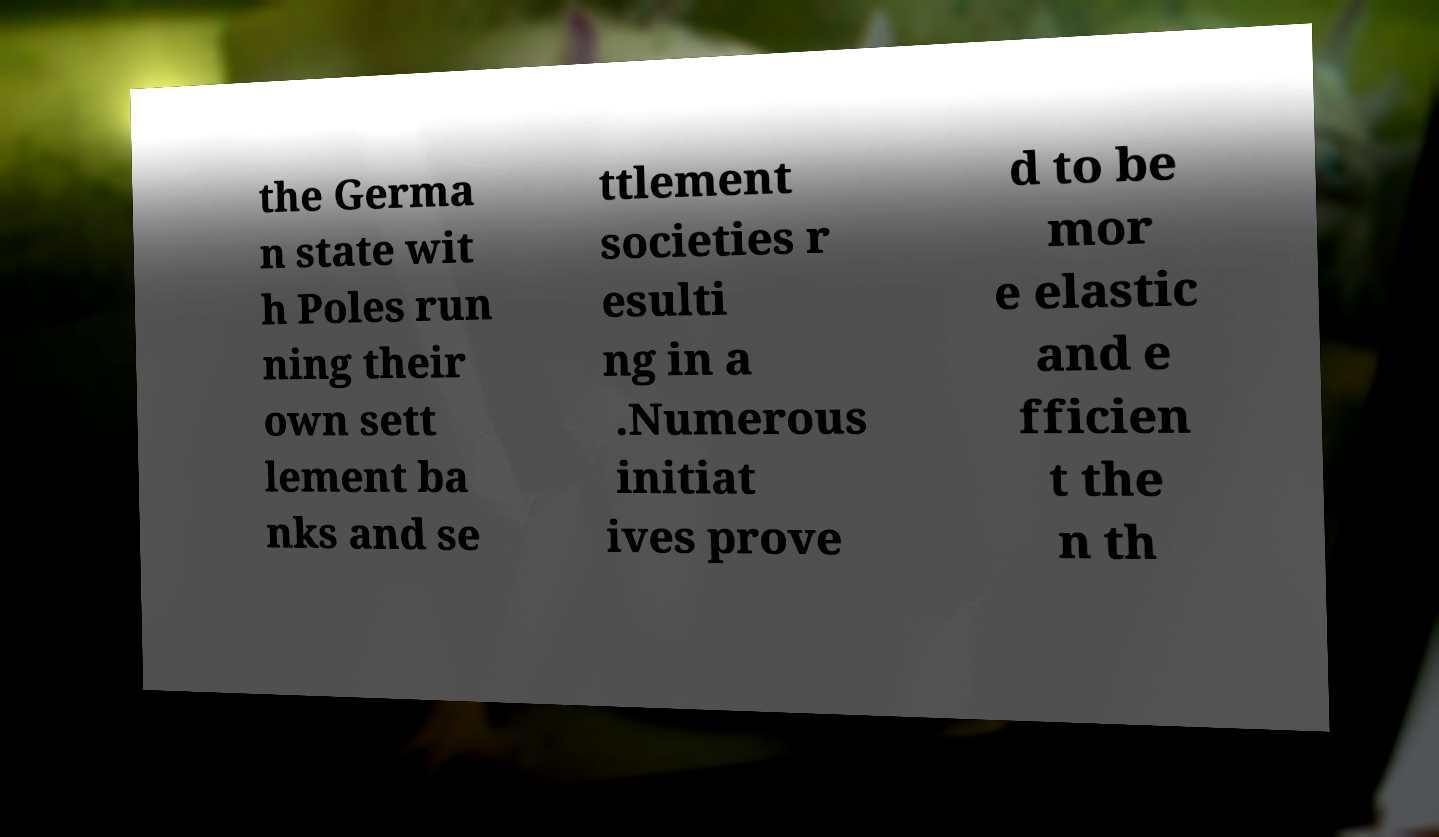What messages or text are displayed in this image? I need them in a readable, typed format. the Germa n state wit h Poles run ning their own sett lement ba nks and se ttlement societies r esulti ng in a .Numerous initiat ives prove d to be mor e elastic and e fficien t the n th 